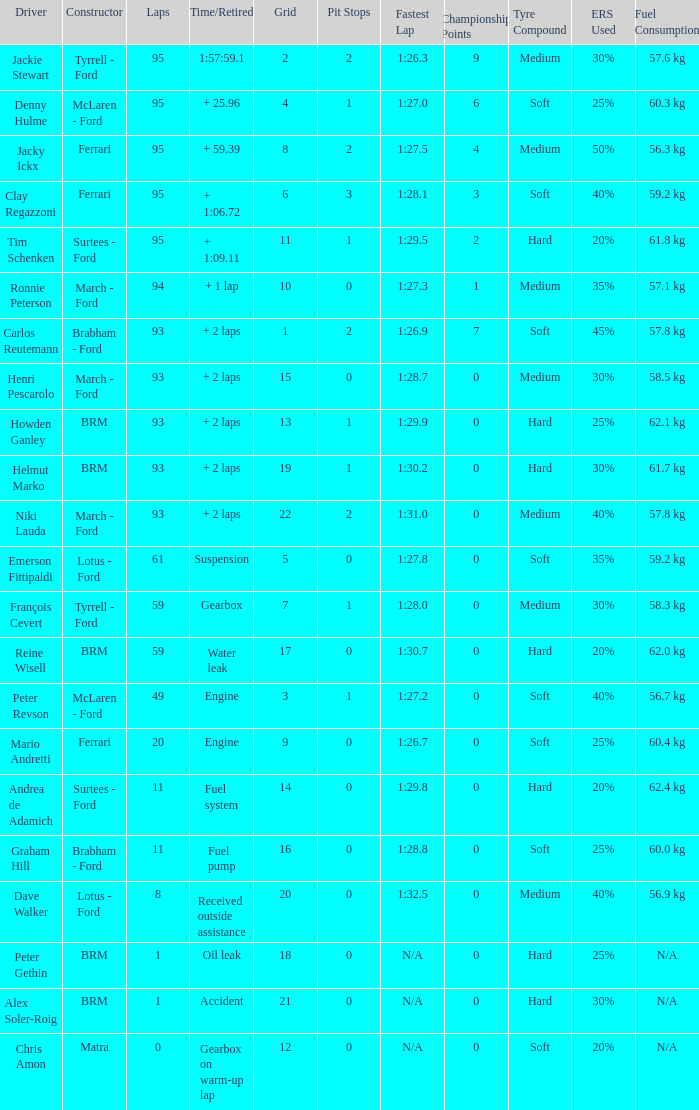Which grid has less than 11 laps, and a Time/Retired of accident? 21.0. 